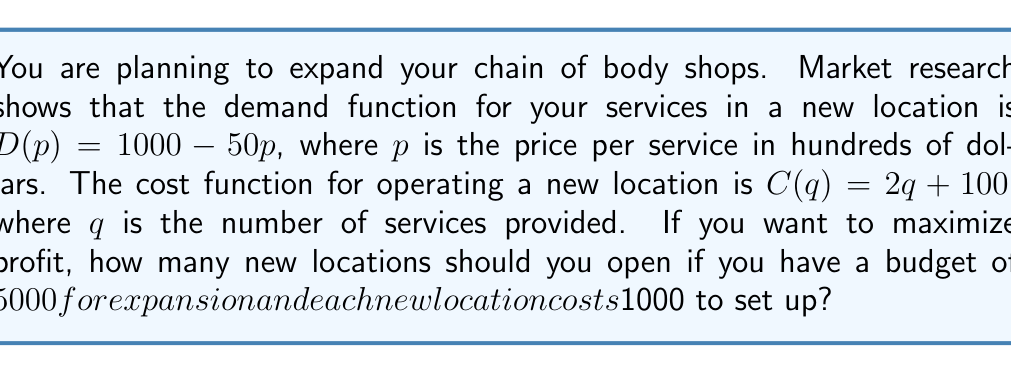Show me your answer to this math problem. 1. Find the optimal price and quantity for each location:
   Profit function: $\pi(q) = pq - C(q)$
   $\pi(q) = (20 - \frac{q}{50})q - (2q + 100)$
   $\pi(q) = 20q - \frac{q^2}{50} - 2q - 100$
   $\pi(q) = 18q - \frac{q^2}{50} - 100$

2. Find the maximum profit by setting $\frac{d\pi}{dq} = 0$:
   $\frac{d\pi}{dq} = 18 - \frac{q}{25} = 0$
   $q = 450$

3. Calculate the maximum profit per location:
   $\pi(450) = 18(450) - \frac{450^2}{50} - 100 = 3950$

4. Calculate the number of locations that can be opened:
   Budget for new locations = $5000 - 1000 = 4000$
   Number of locations = $\frac{4000}{1000} = 4$

5. Check if opening 4 locations is profitable:
   Total profit = $4 * 3950 = 15800$
   This is greater than the setup cost of $4000$, so it's profitable.

Therefore, you should open 4 new locations to maximize profit within your budget constraints.
Answer: 4 new locations 